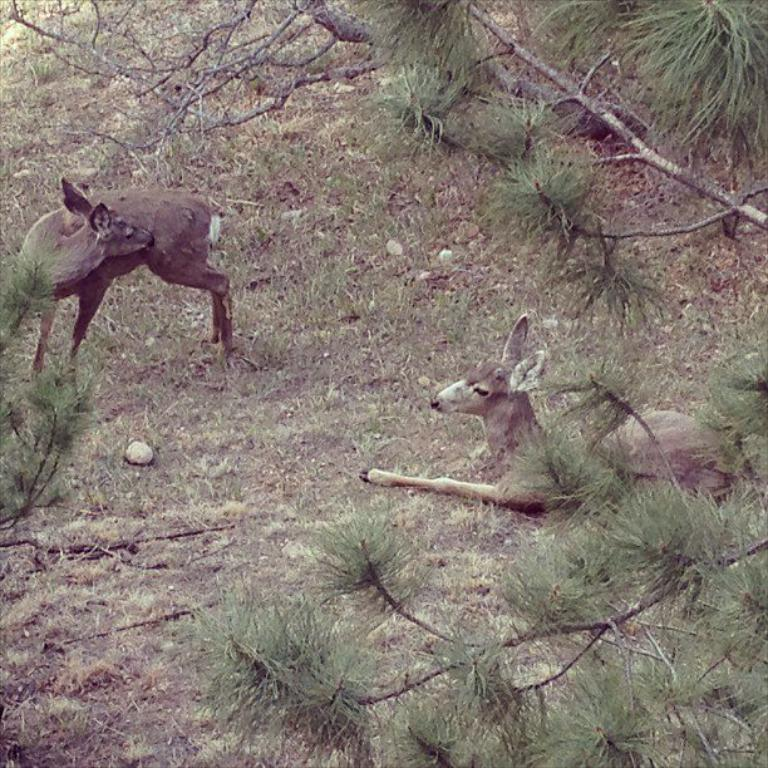How many deer are visible in the image? There are two deer visible in the image, one on the right side and one on the left side. What type of environment is depicted in the image? The image shows greenery around the area, suggesting a natural or outdoor setting. Where is the veil located in the image? There is no veil present in the image. How many men are visible in the image? There are no men visible in the image. 